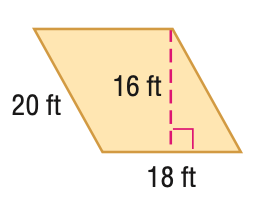Question: Find the area of the parallelogram. Round to the nearest tenth if necessary.
Choices:
A. 268
B. 288
C. 320
D. 360
Answer with the letter. Answer: B 